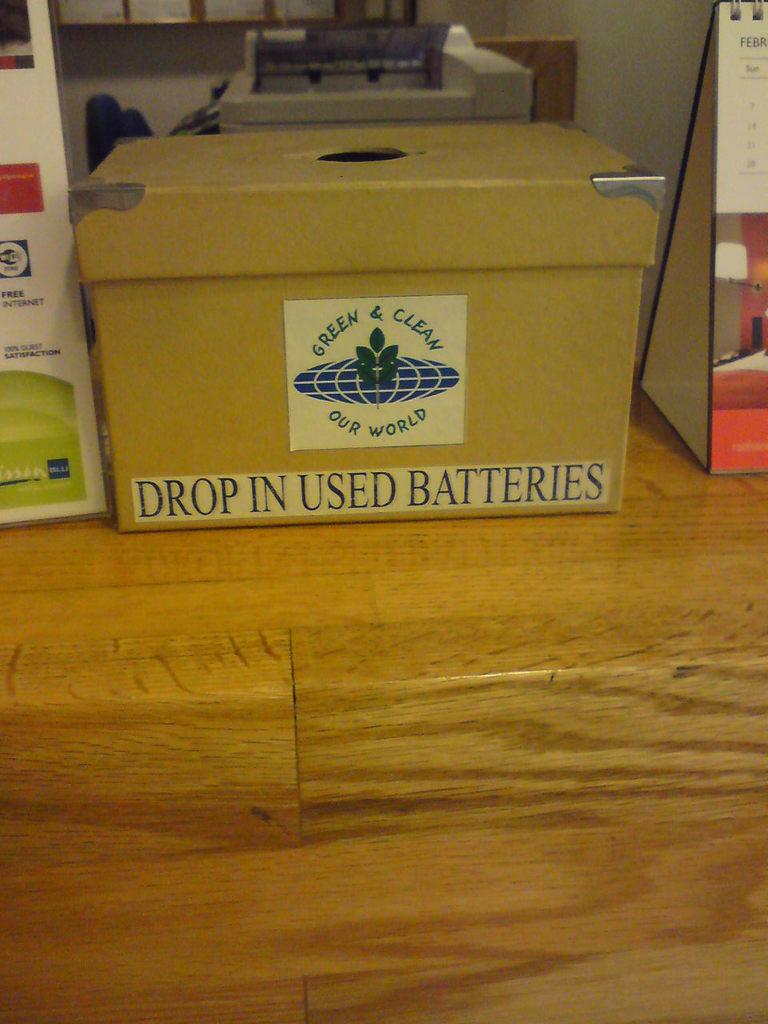What are you supposed to drop in this box?
Keep it short and to the point. Used batteries. What should be kept green & clean?
Provide a succinct answer. Our world. 